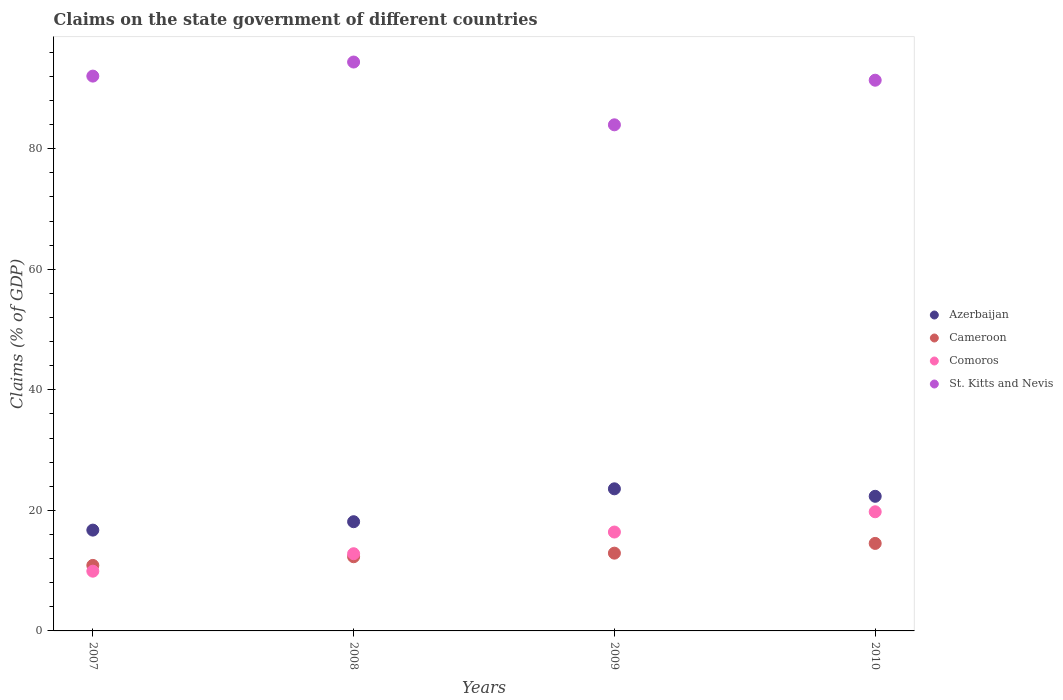Is the number of dotlines equal to the number of legend labels?
Ensure brevity in your answer.  Yes. What is the percentage of GDP claimed on the state government in Comoros in 2009?
Your answer should be compact. 16.4. Across all years, what is the maximum percentage of GDP claimed on the state government in Comoros?
Give a very brief answer. 19.77. Across all years, what is the minimum percentage of GDP claimed on the state government in Azerbaijan?
Make the answer very short. 16.73. What is the total percentage of GDP claimed on the state government in Comoros in the graph?
Your answer should be compact. 58.89. What is the difference between the percentage of GDP claimed on the state government in Comoros in 2007 and that in 2008?
Your answer should be very brief. -2.9. What is the difference between the percentage of GDP claimed on the state government in Cameroon in 2009 and the percentage of GDP claimed on the state government in St. Kitts and Nevis in 2010?
Ensure brevity in your answer.  -78.46. What is the average percentage of GDP claimed on the state government in Cameroon per year?
Your answer should be compact. 12.65. In the year 2010, what is the difference between the percentage of GDP claimed on the state government in St. Kitts and Nevis and percentage of GDP claimed on the state government in Comoros?
Your answer should be compact. 71.6. What is the ratio of the percentage of GDP claimed on the state government in Cameroon in 2007 to that in 2009?
Provide a short and direct response. 0.84. What is the difference between the highest and the second highest percentage of GDP claimed on the state government in St. Kitts and Nevis?
Keep it short and to the point. 2.33. What is the difference between the highest and the lowest percentage of GDP claimed on the state government in Comoros?
Your answer should be very brief. 9.86. In how many years, is the percentage of GDP claimed on the state government in Cameroon greater than the average percentage of GDP claimed on the state government in Cameroon taken over all years?
Ensure brevity in your answer.  2. Is the sum of the percentage of GDP claimed on the state government in St. Kitts and Nevis in 2008 and 2010 greater than the maximum percentage of GDP claimed on the state government in Azerbaijan across all years?
Make the answer very short. Yes. Does the percentage of GDP claimed on the state government in St. Kitts and Nevis monotonically increase over the years?
Provide a succinct answer. No. Is the percentage of GDP claimed on the state government in St. Kitts and Nevis strictly greater than the percentage of GDP claimed on the state government in Cameroon over the years?
Keep it short and to the point. Yes. Is the percentage of GDP claimed on the state government in St. Kitts and Nevis strictly less than the percentage of GDP claimed on the state government in Azerbaijan over the years?
Give a very brief answer. No. How many dotlines are there?
Make the answer very short. 4. How many years are there in the graph?
Your answer should be compact. 4. Where does the legend appear in the graph?
Your answer should be compact. Center right. How many legend labels are there?
Offer a very short reply. 4. What is the title of the graph?
Make the answer very short. Claims on the state government of different countries. What is the label or title of the X-axis?
Offer a very short reply. Years. What is the label or title of the Y-axis?
Your answer should be compact. Claims (% of GDP). What is the Claims (% of GDP) in Azerbaijan in 2007?
Keep it short and to the point. 16.73. What is the Claims (% of GDP) of Cameroon in 2007?
Keep it short and to the point. 10.87. What is the Claims (% of GDP) in Comoros in 2007?
Ensure brevity in your answer.  9.91. What is the Claims (% of GDP) in St. Kitts and Nevis in 2007?
Make the answer very short. 92.05. What is the Claims (% of GDP) of Azerbaijan in 2008?
Provide a succinct answer. 18.12. What is the Claims (% of GDP) of Cameroon in 2008?
Your answer should be very brief. 12.31. What is the Claims (% of GDP) of Comoros in 2008?
Your answer should be very brief. 12.81. What is the Claims (% of GDP) in St. Kitts and Nevis in 2008?
Offer a very short reply. 94.38. What is the Claims (% of GDP) of Azerbaijan in 2009?
Keep it short and to the point. 23.58. What is the Claims (% of GDP) in Cameroon in 2009?
Your response must be concise. 12.9. What is the Claims (% of GDP) in Comoros in 2009?
Provide a short and direct response. 16.4. What is the Claims (% of GDP) of St. Kitts and Nevis in 2009?
Give a very brief answer. 83.97. What is the Claims (% of GDP) of Azerbaijan in 2010?
Your answer should be very brief. 22.33. What is the Claims (% of GDP) in Cameroon in 2010?
Provide a succinct answer. 14.52. What is the Claims (% of GDP) of Comoros in 2010?
Give a very brief answer. 19.77. What is the Claims (% of GDP) of St. Kitts and Nevis in 2010?
Your answer should be compact. 91.37. Across all years, what is the maximum Claims (% of GDP) of Azerbaijan?
Your answer should be compact. 23.58. Across all years, what is the maximum Claims (% of GDP) of Cameroon?
Provide a short and direct response. 14.52. Across all years, what is the maximum Claims (% of GDP) of Comoros?
Provide a succinct answer. 19.77. Across all years, what is the maximum Claims (% of GDP) of St. Kitts and Nevis?
Your answer should be very brief. 94.38. Across all years, what is the minimum Claims (% of GDP) in Azerbaijan?
Your response must be concise. 16.73. Across all years, what is the minimum Claims (% of GDP) of Cameroon?
Offer a terse response. 10.87. Across all years, what is the minimum Claims (% of GDP) of Comoros?
Make the answer very short. 9.91. Across all years, what is the minimum Claims (% of GDP) of St. Kitts and Nevis?
Offer a terse response. 83.97. What is the total Claims (% of GDP) in Azerbaijan in the graph?
Your answer should be very brief. 80.75. What is the total Claims (% of GDP) of Cameroon in the graph?
Offer a very short reply. 50.6. What is the total Claims (% of GDP) of Comoros in the graph?
Give a very brief answer. 58.89. What is the total Claims (% of GDP) of St. Kitts and Nevis in the graph?
Your response must be concise. 361.76. What is the difference between the Claims (% of GDP) in Azerbaijan in 2007 and that in 2008?
Your response must be concise. -1.39. What is the difference between the Claims (% of GDP) in Cameroon in 2007 and that in 2008?
Your answer should be compact. -1.44. What is the difference between the Claims (% of GDP) of Comoros in 2007 and that in 2008?
Your answer should be very brief. -2.9. What is the difference between the Claims (% of GDP) in St. Kitts and Nevis in 2007 and that in 2008?
Your answer should be very brief. -2.33. What is the difference between the Claims (% of GDP) in Azerbaijan in 2007 and that in 2009?
Offer a very short reply. -6.85. What is the difference between the Claims (% of GDP) in Cameroon in 2007 and that in 2009?
Make the answer very short. -2.03. What is the difference between the Claims (% of GDP) of Comoros in 2007 and that in 2009?
Offer a very short reply. -6.49. What is the difference between the Claims (% of GDP) in St. Kitts and Nevis in 2007 and that in 2009?
Provide a short and direct response. 8.08. What is the difference between the Claims (% of GDP) of Azerbaijan in 2007 and that in 2010?
Ensure brevity in your answer.  -5.61. What is the difference between the Claims (% of GDP) in Cameroon in 2007 and that in 2010?
Provide a short and direct response. -3.65. What is the difference between the Claims (% of GDP) of Comoros in 2007 and that in 2010?
Your response must be concise. -9.86. What is the difference between the Claims (% of GDP) of St. Kitts and Nevis in 2007 and that in 2010?
Your answer should be compact. 0.68. What is the difference between the Claims (% of GDP) of Azerbaijan in 2008 and that in 2009?
Provide a succinct answer. -5.46. What is the difference between the Claims (% of GDP) in Cameroon in 2008 and that in 2009?
Offer a terse response. -0.59. What is the difference between the Claims (% of GDP) in Comoros in 2008 and that in 2009?
Your answer should be compact. -3.6. What is the difference between the Claims (% of GDP) in St. Kitts and Nevis in 2008 and that in 2009?
Your response must be concise. 10.42. What is the difference between the Claims (% of GDP) of Azerbaijan in 2008 and that in 2010?
Offer a very short reply. -4.22. What is the difference between the Claims (% of GDP) of Cameroon in 2008 and that in 2010?
Ensure brevity in your answer.  -2.21. What is the difference between the Claims (% of GDP) of Comoros in 2008 and that in 2010?
Provide a succinct answer. -6.96. What is the difference between the Claims (% of GDP) in St. Kitts and Nevis in 2008 and that in 2010?
Provide a short and direct response. 3.02. What is the difference between the Claims (% of GDP) in Azerbaijan in 2009 and that in 2010?
Your response must be concise. 1.24. What is the difference between the Claims (% of GDP) of Cameroon in 2009 and that in 2010?
Provide a succinct answer. -1.62. What is the difference between the Claims (% of GDP) of Comoros in 2009 and that in 2010?
Provide a succinct answer. -3.36. What is the difference between the Claims (% of GDP) in St. Kitts and Nevis in 2009 and that in 2010?
Make the answer very short. -7.4. What is the difference between the Claims (% of GDP) in Azerbaijan in 2007 and the Claims (% of GDP) in Cameroon in 2008?
Your answer should be very brief. 4.42. What is the difference between the Claims (% of GDP) in Azerbaijan in 2007 and the Claims (% of GDP) in Comoros in 2008?
Keep it short and to the point. 3.92. What is the difference between the Claims (% of GDP) of Azerbaijan in 2007 and the Claims (% of GDP) of St. Kitts and Nevis in 2008?
Your answer should be very brief. -77.66. What is the difference between the Claims (% of GDP) in Cameroon in 2007 and the Claims (% of GDP) in Comoros in 2008?
Offer a very short reply. -1.94. What is the difference between the Claims (% of GDP) in Cameroon in 2007 and the Claims (% of GDP) in St. Kitts and Nevis in 2008?
Ensure brevity in your answer.  -83.51. What is the difference between the Claims (% of GDP) of Comoros in 2007 and the Claims (% of GDP) of St. Kitts and Nevis in 2008?
Make the answer very short. -84.47. What is the difference between the Claims (% of GDP) of Azerbaijan in 2007 and the Claims (% of GDP) of Cameroon in 2009?
Provide a succinct answer. 3.82. What is the difference between the Claims (% of GDP) in Azerbaijan in 2007 and the Claims (% of GDP) in Comoros in 2009?
Provide a short and direct response. 0.32. What is the difference between the Claims (% of GDP) of Azerbaijan in 2007 and the Claims (% of GDP) of St. Kitts and Nevis in 2009?
Keep it short and to the point. -67.24. What is the difference between the Claims (% of GDP) of Cameroon in 2007 and the Claims (% of GDP) of Comoros in 2009?
Your answer should be very brief. -5.53. What is the difference between the Claims (% of GDP) of Cameroon in 2007 and the Claims (% of GDP) of St. Kitts and Nevis in 2009?
Provide a short and direct response. -73.1. What is the difference between the Claims (% of GDP) of Comoros in 2007 and the Claims (% of GDP) of St. Kitts and Nevis in 2009?
Make the answer very short. -74.06. What is the difference between the Claims (% of GDP) in Azerbaijan in 2007 and the Claims (% of GDP) in Cameroon in 2010?
Offer a terse response. 2.21. What is the difference between the Claims (% of GDP) of Azerbaijan in 2007 and the Claims (% of GDP) of Comoros in 2010?
Provide a short and direct response. -3.04. What is the difference between the Claims (% of GDP) of Azerbaijan in 2007 and the Claims (% of GDP) of St. Kitts and Nevis in 2010?
Keep it short and to the point. -74.64. What is the difference between the Claims (% of GDP) of Cameroon in 2007 and the Claims (% of GDP) of Comoros in 2010?
Give a very brief answer. -8.9. What is the difference between the Claims (% of GDP) of Cameroon in 2007 and the Claims (% of GDP) of St. Kitts and Nevis in 2010?
Provide a succinct answer. -80.5. What is the difference between the Claims (% of GDP) in Comoros in 2007 and the Claims (% of GDP) in St. Kitts and Nevis in 2010?
Offer a very short reply. -81.45. What is the difference between the Claims (% of GDP) of Azerbaijan in 2008 and the Claims (% of GDP) of Cameroon in 2009?
Provide a succinct answer. 5.22. What is the difference between the Claims (% of GDP) of Azerbaijan in 2008 and the Claims (% of GDP) of Comoros in 2009?
Offer a terse response. 1.71. What is the difference between the Claims (% of GDP) of Azerbaijan in 2008 and the Claims (% of GDP) of St. Kitts and Nevis in 2009?
Offer a terse response. -65.85. What is the difference between the Claims (% of GDP) in Cameroon in 2008 and the Claims (% of GDP) in Comoros in 2009?
Make the answer very short. -4.1. What is the difference between the Claims (% of GDP) in Cameroon in 2008 and the Claims (% of GDP) in St. Kitts and Nevis in 2009?
Provide a succinct answer. -71.66. What is the difference between the Claims (% of GDP) in Comoros in 2008 and the Claims (% of GDP) in St. Kitts and Nevis in 2009?
Your answer should be compact. -71.16. What is the difference between the Claims (% of GDP) in Azerbaijan in 2008 and the Claims (% of GDP) in Cameroon in 2010?
Provide a short and direct response. 3.6. What is the difference between the Claims (% of GDP) of Azerbaijan in 2008 and the Claims (% of GDP) of Comoros in 2010?
Offer a terse response. -1.65. What is the difference between the Claims (% of GDP) in Azerbaijan in 2008 and the Claims (% of GDP) in St. Kitts and Nevis in 2010?
Your answer should be very brief. -73.25. What is the difference between the Claims (% of GDP) of Cameroon in 2008 and the Claims (% of GDP) of Comoros in 2010?
Your answer should be very brief. -7.46. What is the difference between the Claims (% of GDP) of Cameroon in 2008 and the Claims (% of GDP) of St. Kitts and Nevis in 2010?
Ensure brevity in your answer.  -79.06. What is the difference between the Claims (% of GDP) in Comoros in 2008 and the Claims (% of GDP) in St. Kitts and Nevis in 2010?
Ensure brevity in your answer.  -78.56. What is the difference between the Claims (% of GDP) of Azerbaijan in 2009 and the Claims (% of GDP) of Cameroon in 2010?
Keep it short and to the point. 9.06. What is the difference between the Claims (% of GDP) in Azerbaijan in 2009 and the Claims (% of GDP) in Comoros in 2010?
Provide a short and direct response. 3.81. What is the difference between the Claims (% of GDP) of Azerbaijan in 2009 and the Claims (% of GDP) of St. Kitts and Nevis in 2010?
Provide a short and direct response. -67.79. What is the difference between the Claims (% of GDP) of Cameroon in 2009 and the Claims (% of GDP) of Comoros in 2010?
Offer a very short reply. -6.87. What is the difference between the Claims (% of GDP) in Cameroon in 2009 and the Claims (% of GDP) in St. Kitts and Nevis in 2010?
Provide a short and direct response. -78.46. What is the difference between the Claims (% of GDP) in Comoros in 2009 and the Claims (% of GDP) in St. Kitts and Nevis in 2010?
Keep it short and to the point. -74.96. What is the average Claims (% of GDP) in Azerbaijan per year?
Offer a very short reply. 20.19. What is the average Claims (% of GDP) in Cameroon per year?
Give a very brief answer. 12.65. What is the average Claims (% of GDP) in Comoros per year?
Your response must be concise. 14.72. What is the average Claims (% of GDP) of St. Kitts and Nevis per year?
Give a very brief answer. 90.44. In the year 2007, what is the difference between the Claims (% of GDP) in Azerbaijan and Claims (% of GDP) in Cameroon?
Provide a short and direct response. 5.86. In the year 2007, what is the difference between the Claims (% of GDP) in Azerbaijan and Claims (% of GDP) in Comoros?
Ensure brevity in your answer.  6.81. In the year 2007, what is the difference between the Claims (% of GDP) in Azerbaijan and Claims (% of GDP) in St. Kitts and Nevis?
Offer a terse response. -75.32. In the year 2007, what is the difference between the Claims (% of GDP) in Cameroon and Claims (% of GDP) in Comoros?
Provide a succinct answer. 0.96. In the year 2007, what is the difference between the Claims (% of GDP) of Cameroon and Claims (% of GDP) of St. Kitts and Nevis?
Your answer should be compact. -81.18. In the year 2007, what is the difference between the Claims (% of GDP) of Comoros and Claims (% of GDP) of St. Kitts and Nevis?
Make the answer very short. -82.14. In the year 2008, what is the difference between the Claims (% of GDP) of Azerbaijan and Claims (% of GDP) of Cameroon?
Provide a succinct answer. 5.81. In the year 2008, what is the difference between the Claims (% of GDP) in Azerbaijan and Claims (% of GDP) in Comoros?
Offer a very short reply. 5.31. In the year 2008, what is the difference between the Claims (% of GDP) of Azerbaijan and Claims (% of GDP) of St. Kitts and Nevis?
Your answer should be compact. -76.26. In the year 2008, what is the difference between the Claims (% of GDP) in Cameroon and Claims (% of GDP) in Comoros?
Offer a very short reply. -0.5. In the year 2008, what is the difference between the Claims (% of GDP) in Cameroon and Claims (% of GDP) in St. Kitts and Nevis?
Give a very brief answer. -82.07. In the year 2008, what is the difference between the Claims (% of GDP) of Comoros and Claims (% of GDP) of St. Kitts and Nevis?
Ensure brevity in your answer.  -81.58. In the year 2009, what is the difference between the Claims (% of GDP) in Azerbaijan and Claims (% of GDP) in Cameroon?
Offer a very short reply. 10.67. In the year 2009, what is the difference between the Claims (% of GDP) of Azerbaijan and Claims (% of GDP) of Comoros?
Your response must be concise. 7.17. In the year 2009, what is the difference between the Claims (% of GDP) of Azerbaijan and Claims (% of GDP) of St. Kitts and Nevis?
Ensure brevity in your answer.  -60.39. In the year 2009, what is the difference between the Claims (% of GDP) of Cameroon and Claims (% of GDP) of Comoros?
Make the answer very short. -3.5. In the year 2009, what is the difference between the Claims (% of GDP) in Cameroon and Claims (% of GDP) in St. Kitts and Nevis?
Make the answer very short. -71.06. In the year 2009, what is the difference between the Claims (% of GDP) in Comoros and Claims (% of GDP) in St. Kitts and Nevis?
Offer a very short reply. -67.56. In the year 2010, what is the difference between the Claims (% of GDP) in Azerbaijan and Claims (% of GDP) in Cameroon?
Your answer should be very brief. 7.82. In the year 2010, what is the difference between the Claims (% of GDP) of Azerbaijan and Claims (% of GDP) of Comoros?
Keep it short and to the point. 2.57. In the year 2010, what is the difference between the Claims (% of GDP) of Azerbaijan and Claims (% of GDP) of St. Kitts and Nevis?
Provide a short and direct response. -69.03. In the year 2010, what is the difference between the Claims (% of GDP) of Cameroon and Claims (% of GDP) of Comoros?
Make the answer very short. -5.25. In the year 2010, what is the difference between the Claims (% of GDP) of Cameroon and Claims (% of GDP) of St. Kitts and Nevis?
Give a very brief answer. -76.85. In the year 2010, what is the difference between the Claims (% of GDP) in Comoros and Claims (% of GDP) in St. Kitts and Nevis?
Your answer should be very brief. -71.6. What is the ratio of the Claims (% of GDP) of Azerbaijan in 2007 to that in 2008?
Ensure brevity in your answer.  0.92. What is the ratio of the Claims (% of GDP) of Cameroon in 2007 to that in 2008?
Ensure brevity in your answer.  0.88. What is the ratio of the Claims (% of GDP) of Comoros in 2007 to that in 2008?
Offer a terse response. 0.77. What is the ratio of the Claims (% of GDP) of St. Kitts and Nevis in 2007 to that in 2008?
Provide a succinct answer. 0.98. What is the ratio of the Claims (% of GDP) in Azerbaijan in 2007 to that in 2009?
Your answer should be very brief. 0.71. What is the ratio of the Claims (% of GDP) in Cameroon in 2007 to that in 2009?
Ensure brevity in your answer.  0.84. What is the ratio of the Claims (% of GDP) of Comoros in 2007 to that in 2009?
Keep it short and to the point. 0.6. What is the ratio of the Claims (% of GDP) in St. Kitts and Nevis in 2007 to that in 2009?
Make the answer very short. 1.1. What is the ratio of the Claims (% of GDP) in Azerbaijan in 2007 to that in 2010?
Give a very brief answer. 0.75. What is the ratio of the Claims (% of GDP) of Cameroon in 2007 to that in 2010?
Provide a short and direct response. 0.75. What is the ratio of the Claims (% of GDP) in Comoros in 2007 to that in 2010?
Your answer should be very brief. 0.5. What is the ratio of the Claims (% of GDP) of St. Kitts and Nevis in 2007 to that in 2010?
Provide a short and direct response. 1.01. What is the ratio of the Claims (% of GDP) in Azerbaijan in 2008 to that in 2009?
Your answer should be very brief. 0.77. What is the ratio of the Claims (% of GDP) in Cameroon in 2008 to that in 2009?
Offer a terse response. 0.95. What is the ratio of the Claims (% of GDP) in Comoros in 2008 to that in 2009?
Ensure brevity in your answer.  0.78. What is the ratio of the Claims (% of GDP) of St. Kitts and Nevis in 2008 to that in 2009?
Give a very brief answer. 1.12. What is the ratio of the Claims (% of GDP) of Azerbaijan in 2008 to that in 2010?
Provide a succinct answer. 0.81. What is the ratio of the Claims (% of GDP) in Cameroon in 2008 to that in 2010?
Make the answer very short. 0.85. What is the ratio of the Claims (% of GDP) in Comoros in 2008 to that in 2010?
Offer a terse response. 0.65. What is the ratio of the Claims (% of GDP) in St. Kitts and Nevis in 2008 to that in 2010?
Provide a short and direct response. 1.03. What is the ratio of the Claims (% of GDP) in Azerbaijan in 2009 to that in 2010?
Your answer should be very brief. 1.06. What is the ratio of the Claims (% of GDP) of Cameroon in 2009 to that in 2010?
Provide a short and direct response. 0.89. What is the ratio of the Claims (% of GDP) in Comoros in 2009 to that in 2010?
Your response must be concise. 0.83. What is the ratio of the Claims (% of GDP) in St. Kitts and Nevis in 2009 to that in 2010?
Give a very brief answer. 0.92. What is the difference between the highest and the second highest Claims (% of GDP) of Azerbaijan?
Give a very brief answer. 1.24. What is the difference between the highest and the second highest Claims (% of GDP) of Cameroon?
Give a very brief answer. 1.62. What is the difference between the highest and the second highest Claims (% of GDP) of Comoros?
Offer a terse response. 3.36. What is the difference between the highest and the second highest Claims (% of GDP) of St. Kitts and Nevis?
Give a very brief answer. 2.33. What is the difference between the highest and the lowest Claims (% of GDP) of Azerbaijan?
Your response must be concise. 6.85. What is the difference between the highest and the lowest Claims (% of GDP) in Cameroon?
Your answer should be very brief. 3.65. What is the difference between the highest and the lowest Claims (% of GDP) in Comoros?
Ensure brevity in your answer.  9.86. What is the difference between the highest and the lowest Claims (% of GDP) in St. Kitts and Nevis?
Your answer should be compact. 10.42. 